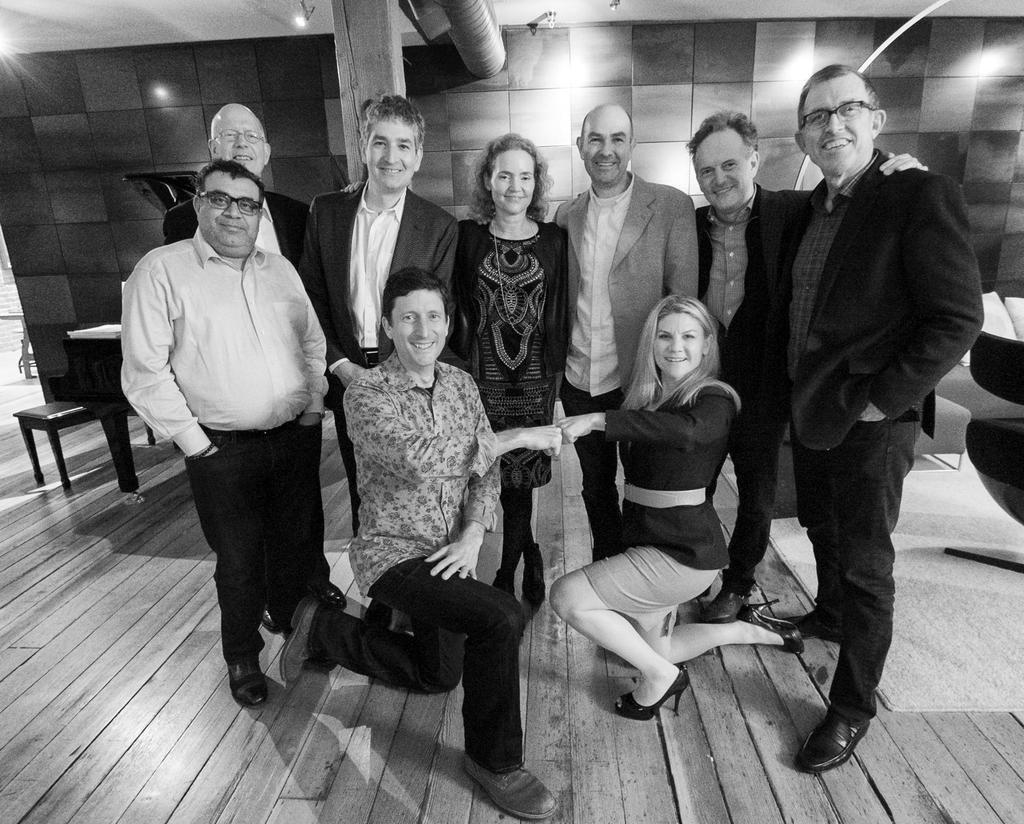In one or two sentences, can you explain what this image depicts? There is a group of people standing here and two people are sitting in front of them they are taking a picture and back of them there is a table and one chair and some lights are present backside we can see one wall which is contains bricks. 